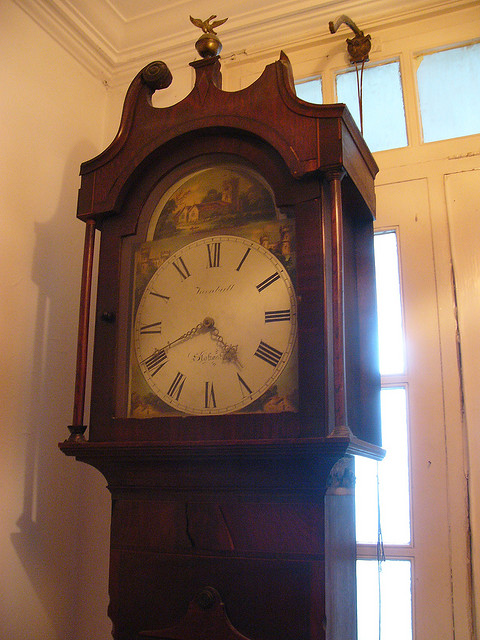Please transcribe the text information in this image. VI 